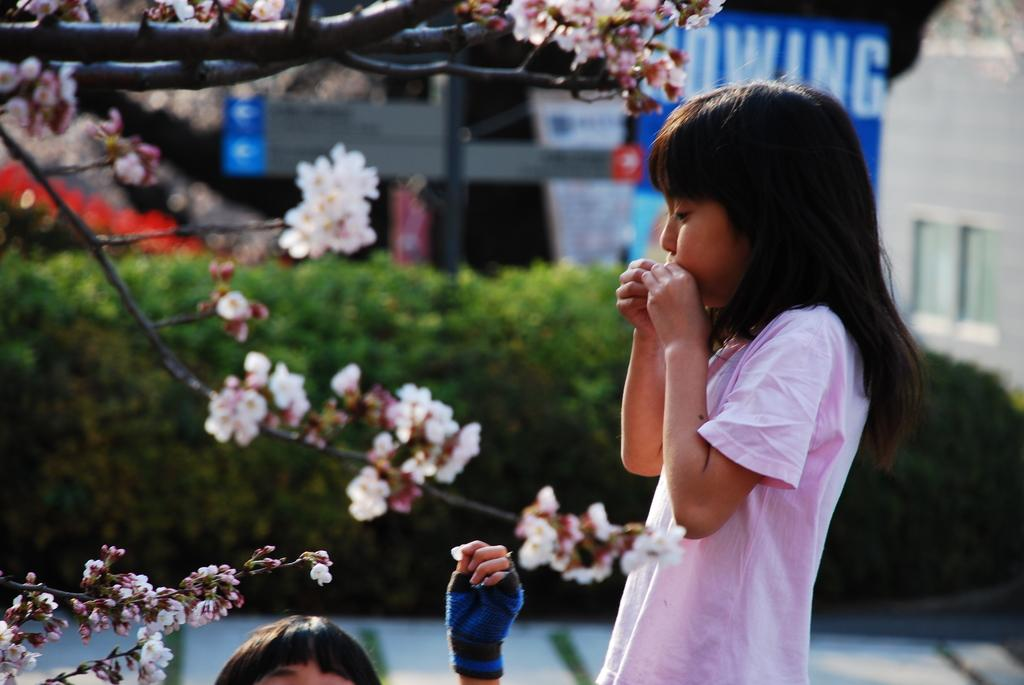Who is the main subject in the image? There is a girl in the image. What is located at the bottom of the image? There is a human head and hand at the bottom of the image. What can be seen in the background of the image? There are flowers with stems, plants, banners, a pole, and walls in the background of the image. What type of verse can be heard recited by the girl in the image? There is no indication in the image that the girl is reciting a verse, so it cannot be determined from the picture. 